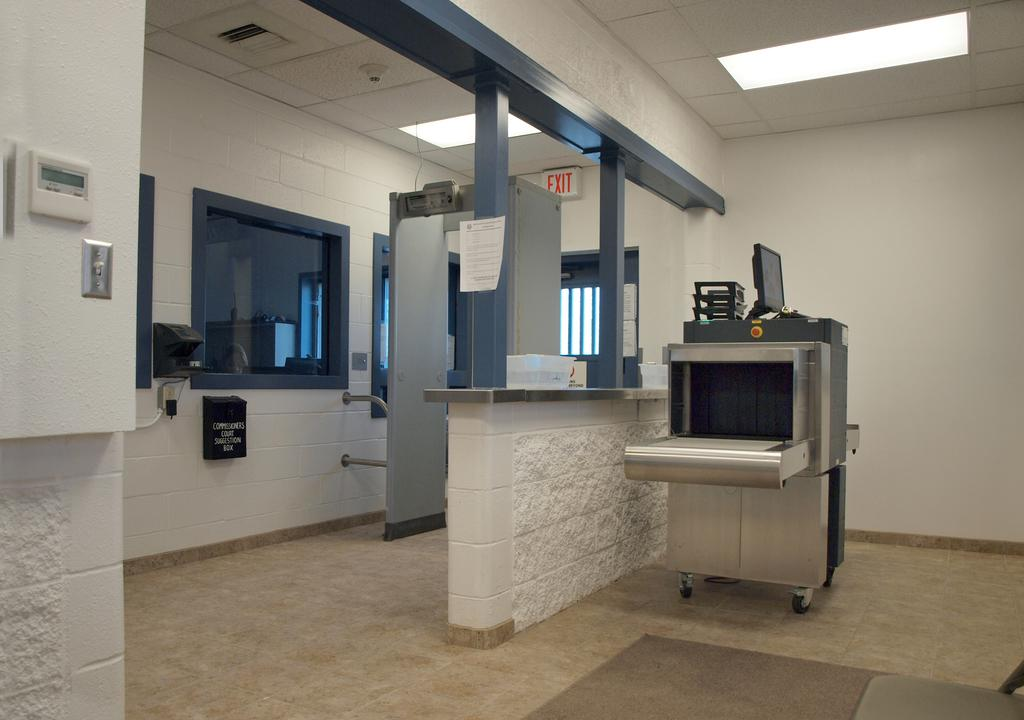Provide a one-sentence caption for the provided image. Entrance to an office building with a suggestion box on the wall for the Commissioners Court. 